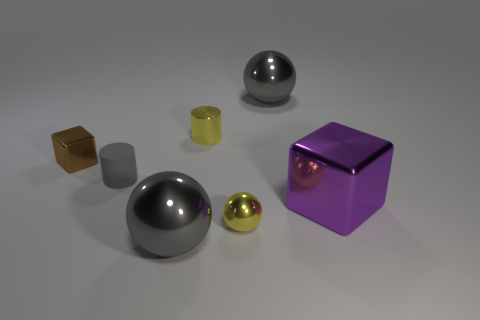Subtract all big gray spheres. How many spheres are left? 1 Subtract all yellow cylinders. How many cylinders are left? 1 Subtract 1 balls. How many balls are left? 2 Subtract all cylinders. How many objects are left? 5 Subtract all blue cylinders. Subtract all green balls. How many cylinders are left? 2 Subtract all gray cylinders. How many red blocks are left? 0 Subtract all tiny yellow balls. Subtract all purple objects. How many objects are left? 5 Add 3 large metallic balls. How many large metallic balls are left? 5 Add 4 tiny yellow metallic cylinders. How many tiny yellow metallic cylinders exist? 5 Add 1 tiny gray rubber balls. How many objects exist? 8 